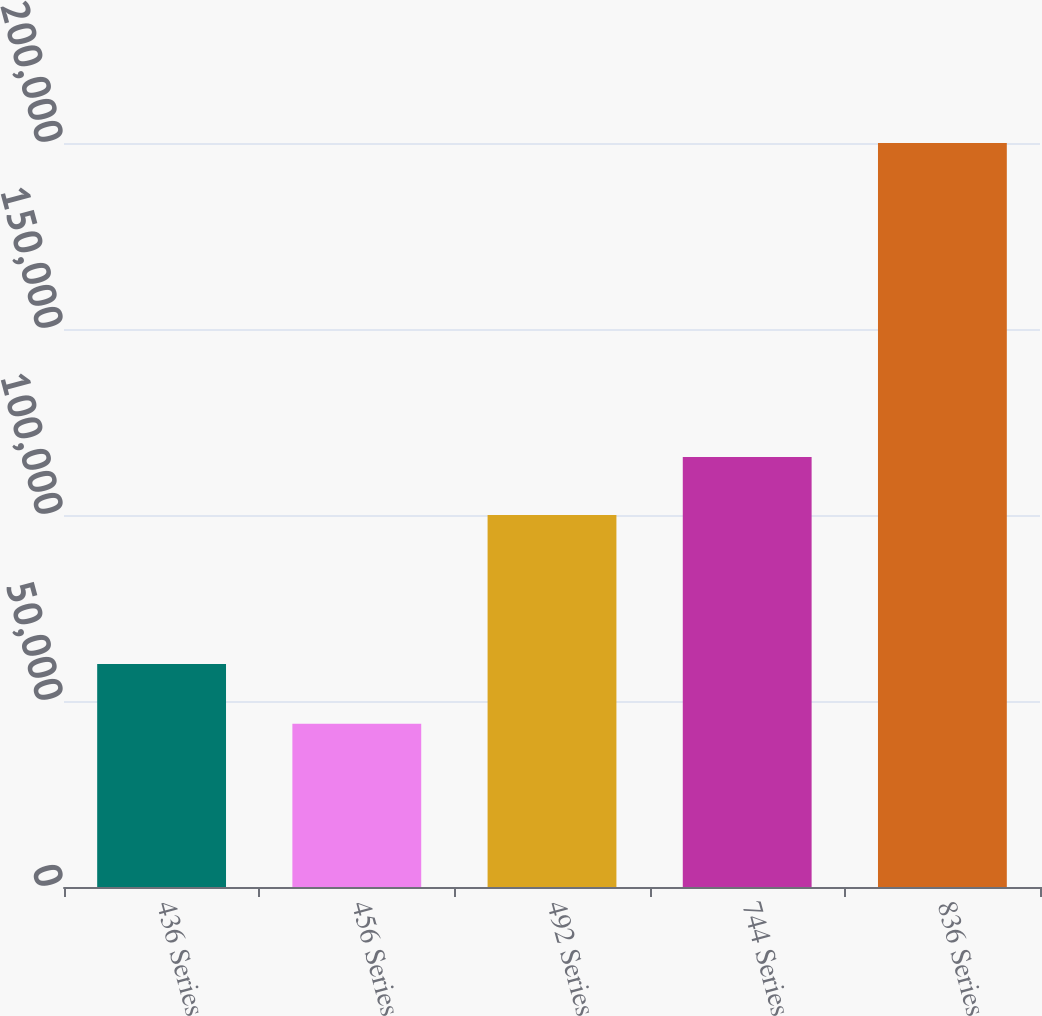Convert chart to OTSL. <chart><loc_0><loc_0><loc_500><loc_500><bar_chart><fcel>436 Series<fcel>456 Series<fcel>492 Series<fcel>744 Series<fcel>836 Series<nl><fcel>59920<fcel>43887<fcel>100000<fcel>115611<fcel>200000<nl></chart> 